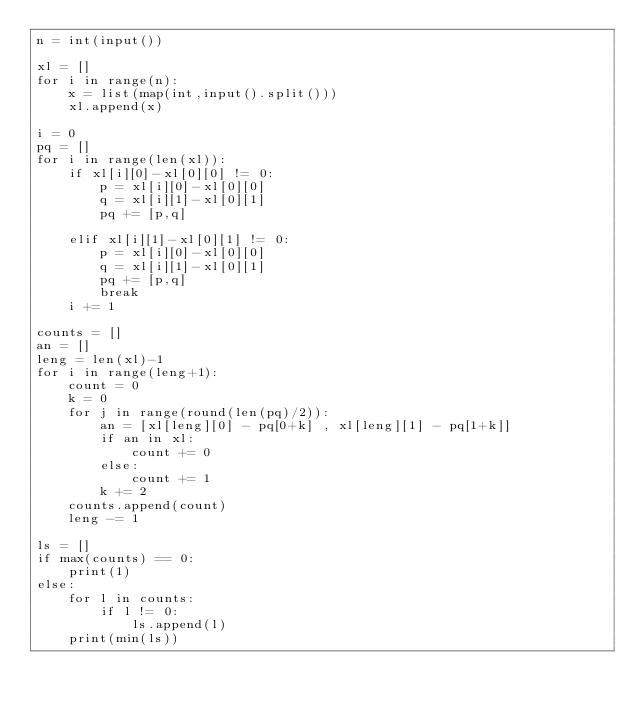Convert code to text. <code><loc_0><loc_0><loc_500><loc_500><_Python_>n = int(input())

xl = []
for i in range(n):
    x = list(map(int,input().split()))
    xl.append(x)

i = 0
pq = []
for i in range(len(xl)):
    if xl[i][0]-xl[0][0] != 0:
        p = xl[i][0]-xl[0][0]
        q = xl[i][1]-xl[0][1]
        pq += [p,q]

    elif xl[i][1]-xl[0][1] != 0:
        p = xl[i][0]-xl[0][0]
        q = xl[i][1]-xl[0][1]
        pq += [p,q]
        break
    i += 1
    
counts = []
an = []
leng = len(xl)-1
for i in range(leng+1):
    count = 0
    k = 0
    for j in range(round(len(pq)/2)):
        an = [xl[leng][0] - pq[0+k] , xl[leng][1] - pq[1+k]]
        if an in xl:
            count += 0
        else:
            count += 1
        k += 2
    counts.append(count)
    leng -= 1

ls = []
if max(counts) == 0:
    print(1)
else:
    for l in counts:
        if l != 0:
            ls.append(l)
    print(min(ls))
</code> 